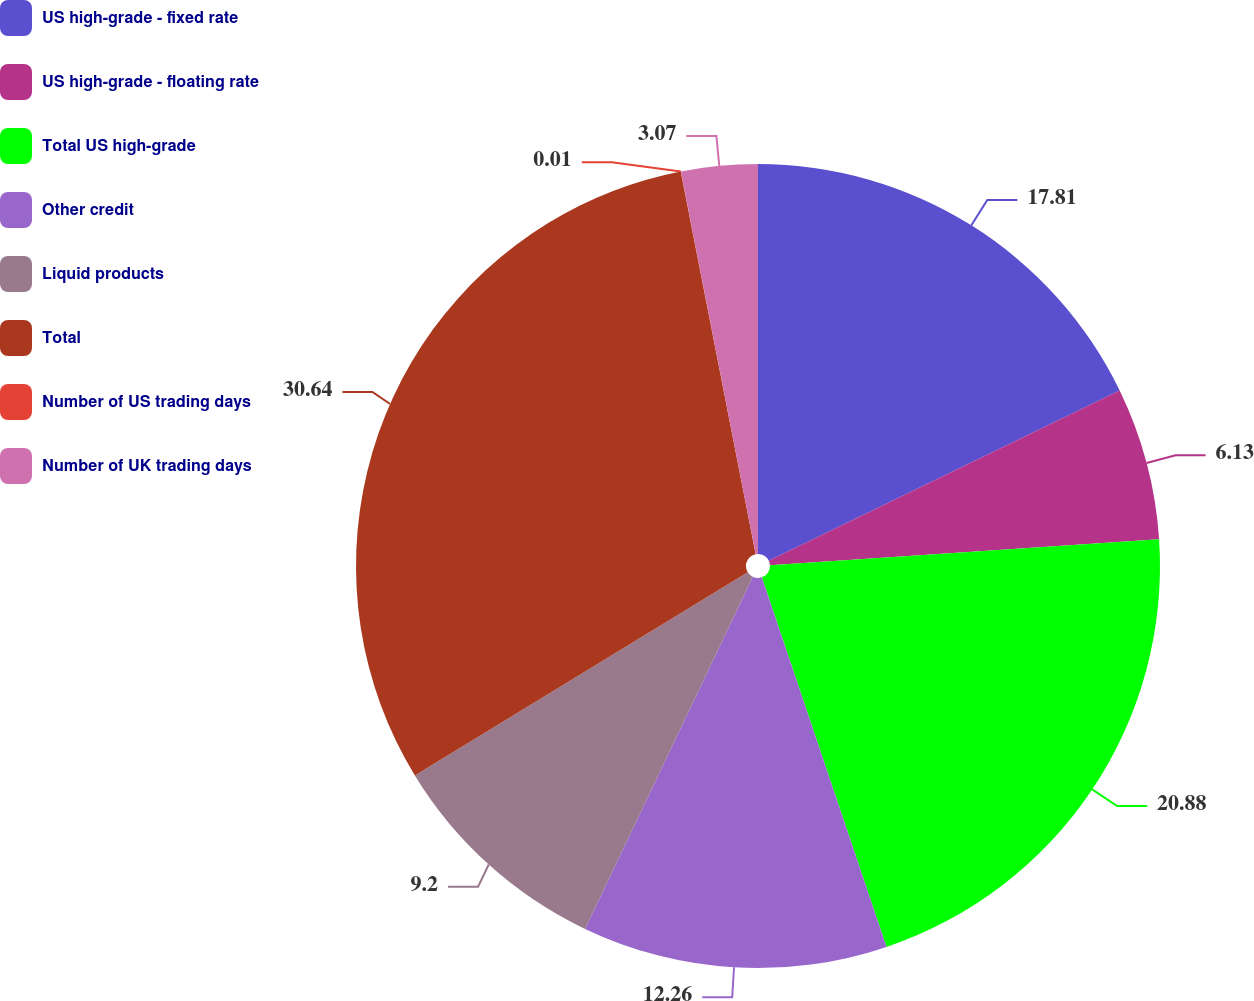Convert chart. <chart><loc_0><loc_0><loc_500><loc_500><pie_chart><fcel>US high-grade - fixed rate<fcel>US high-grade - floating rate<fcel>Total US high-grade<fcel>Other credit<fcel>Liquid products<fcel>Total<fcel>Number of US trading days<fcel>Number of UK trading days<nl><fcel>17.81%<fcel>6.13%<fcel>20.88%<fcel>12.26%<fcel>9.2%<fcel>30.64%<fcel>0.01%<fcel>3.07%<nl></chart> 